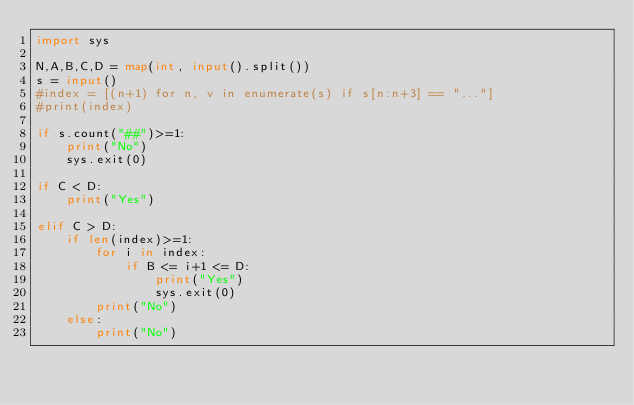Convert code to text. <code><loc_0><loc_0><loc_500><loc_500><_Python_>import sys

N,A,B,C,D = map(int, input().split())
s = input()
#index = [(n+1) for n, v in enumerate(s) if s[n:n+3] == "..."]
#print(index)

if s.count("##")>=1:
    print("No")
    sys.exit(0)

if C < D:
    print("Yes")

elif C > D:
    if len(index)>=1:
        for i in index:
            if B <= i+1 <= D:
                print("Yes")
                sys.exit(0)
        print("No")
    else:
        print("No")
</code> 